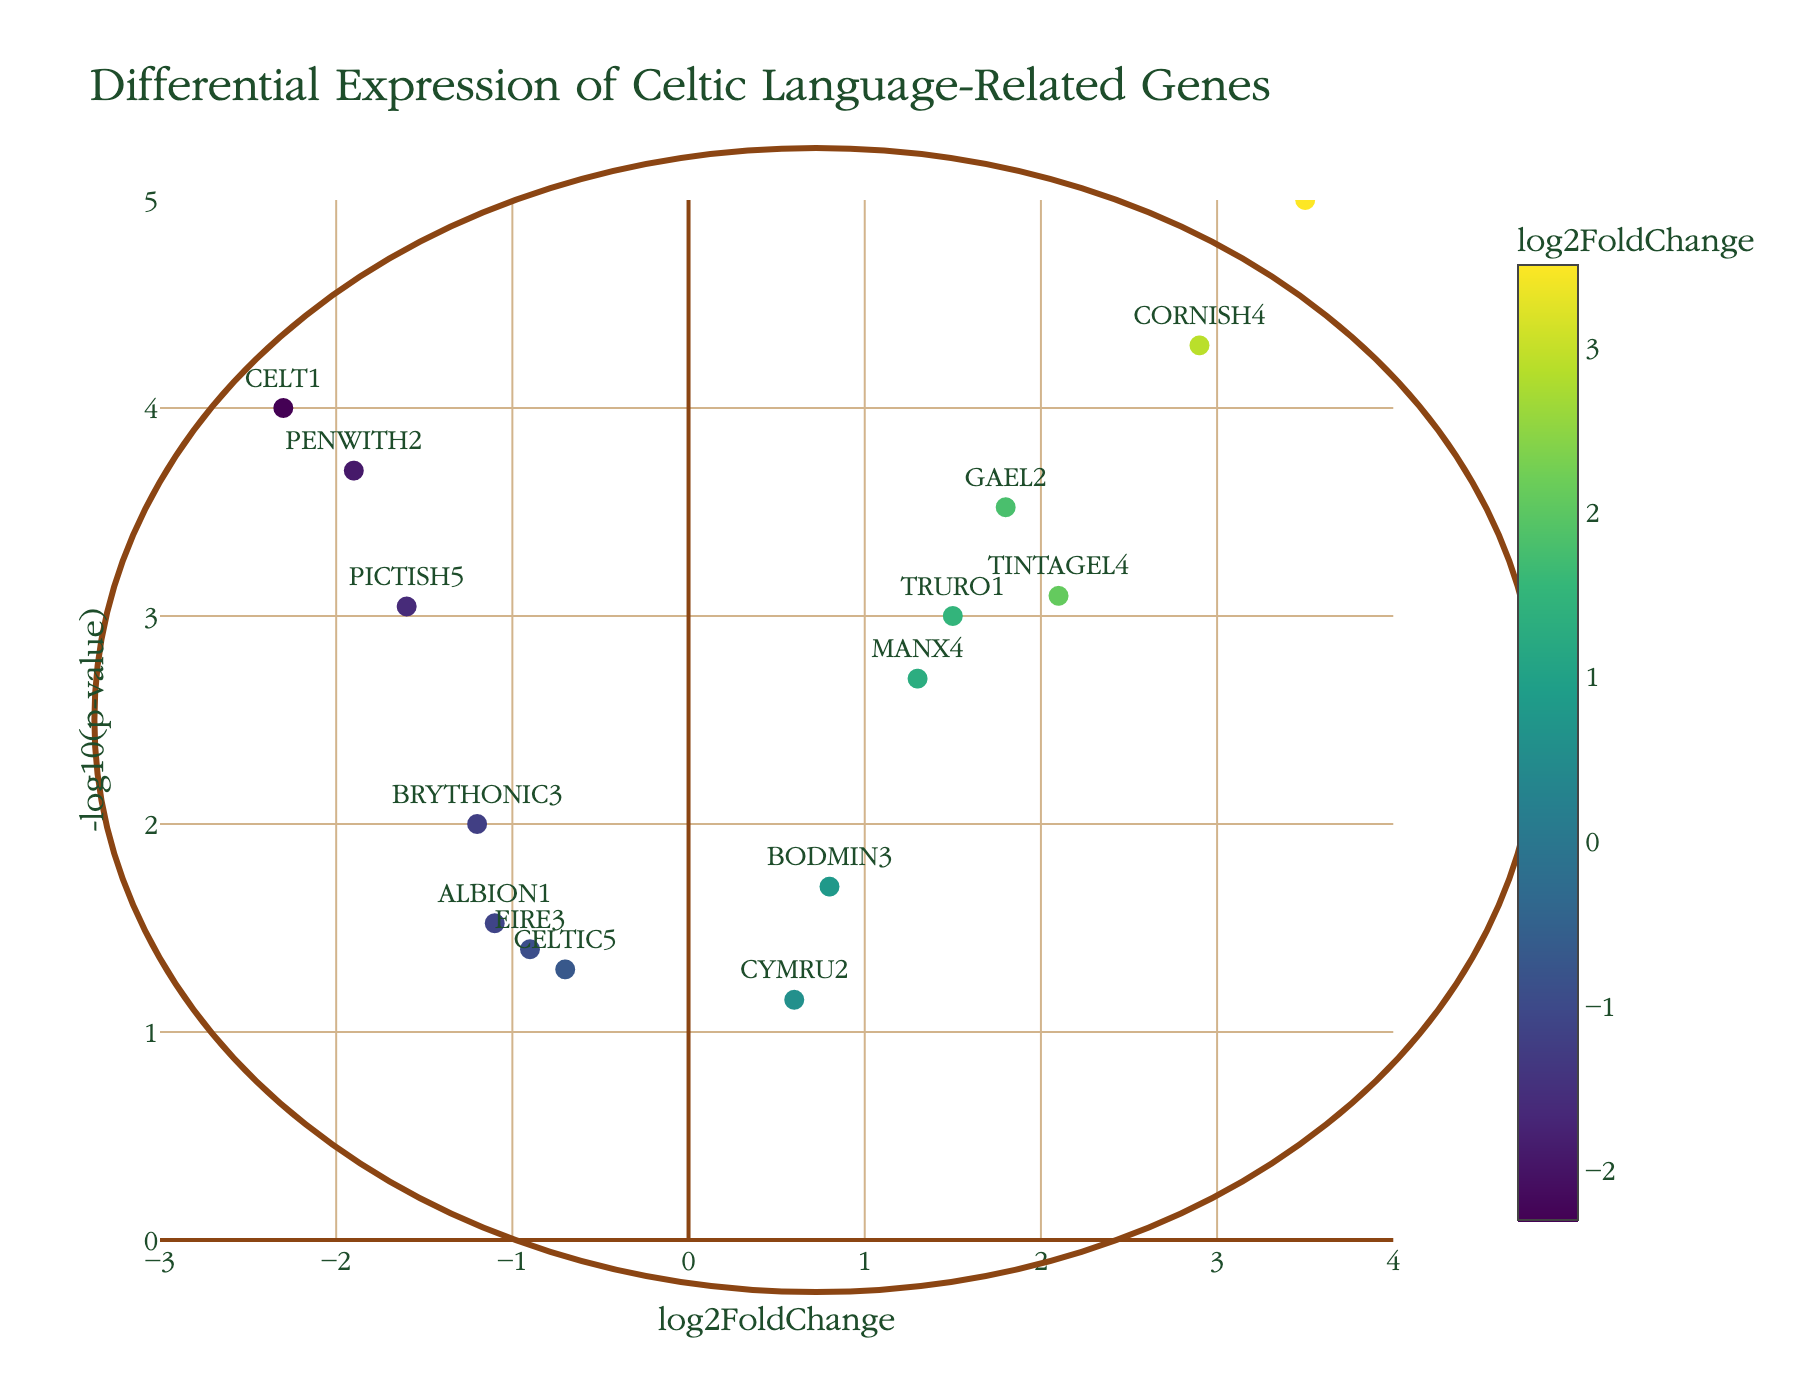What's the title of the plot? The title is usually found at the top of the plot. In this case, the title "Differential Expression of Celtic Language-Related Genes" is clearly labeled at the top.
Answer: Differential Expression of Celtic Language-Related Genes How many genes are shown in the plot? Each marker represents a gene. If we count the markers or data points, there are 15 in total representing 15 genes.
Answer: 15 Which gene has the highest log2FoldChange? By looking at the x-axis, which represents log2FoldChange, the gene furthest to the right will have the highest value. Here, it is "KERNOW1" at 3.5.
Answer: KERNOW1 Which gene has the lowest p-value? A lower p-value corresponds to a higher value on the y-axis (-log10(p-value)). "KERNOW1" reaches the highest point on the y-axis which means it has the lowest p-value.
Answer: KERNOW1 What color represents the highest log2FoldChange? The color scale on the right indicates log2FoldChange. The highest log2FoldChange values are represented by the colors on the higher end of the scale, likely a lighter yellow-green color.
Answer: Light yellow-green How many genes have a -log10(pvalue) greater than 3? To find this, count the number of points above the horizontal line corresponding to -log10(p-value) = 3. Here, "KERNOW1", "CORNISH4", "CELT1", "PENWITH2", "GAEL2", "TRURO1", and "TINTAGEL4" make this criterion.
Answer: 7 Which gene has the closest log2FoldChange to zero but remains positive? By looking near the center of the x-axis but slightly to the right, we find "CYMRU2" with log2FoldChange of 0.6.
Answer: CYMRU2 Between "TRURO1" and "BODMIN3", which gene has a higher -log10(pvalue)? "TRURO1" appears higher on the y-axis than "BODMIN3" does, so it has a higher -log10(p-value).
Answer: TRURO1 Which gene has the lowest log2FoldChange? By looking at the most leftward point on the x-axis, we see "CELT1" with -2.3 as the lowest log2FoldChange.
Answer: CELT1 